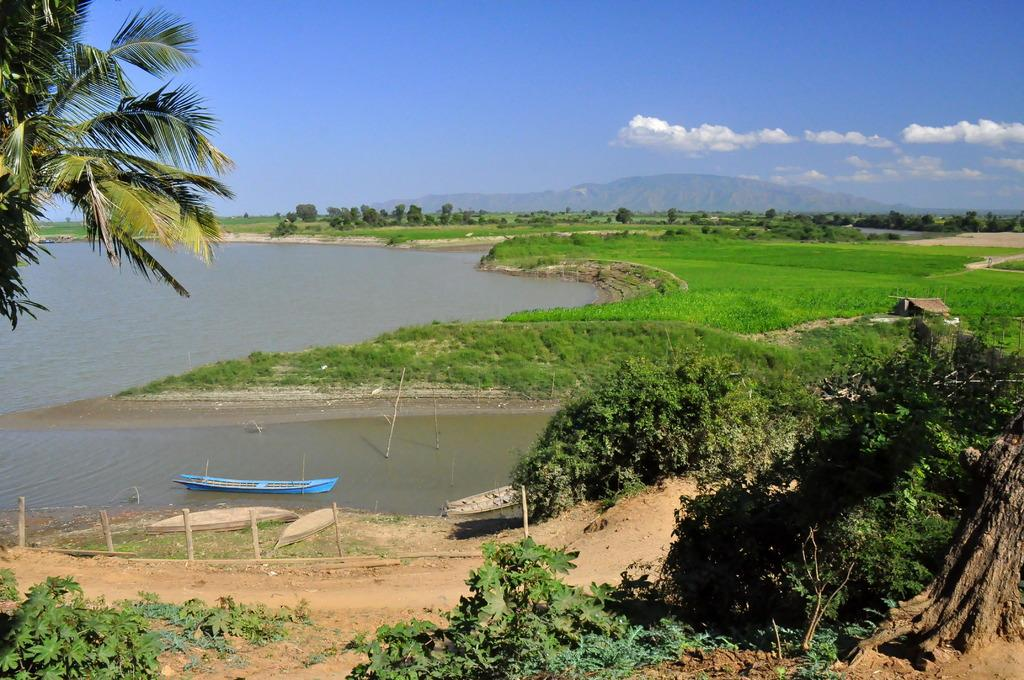What type of vegetation can be seen in the image? There are trees in the image. What type of vehicles are present in the image? There are boats in the image. What is the primary body of water in the image? Water is visible in the image. What type of landscape can be seen in the background of the image? In the background of the image, there are hills. What is visible in the sky in the image? Clouds are present in the background of the image. Can you see a rose growing near the boats in the image? There is no rose visible in the image; it features trees, boats, water, hills, and clouds. What type of spark can be seen coming from the kettle in the image? There is no kettle present in the image; it features trees, boats, water, hills, and clouds. 